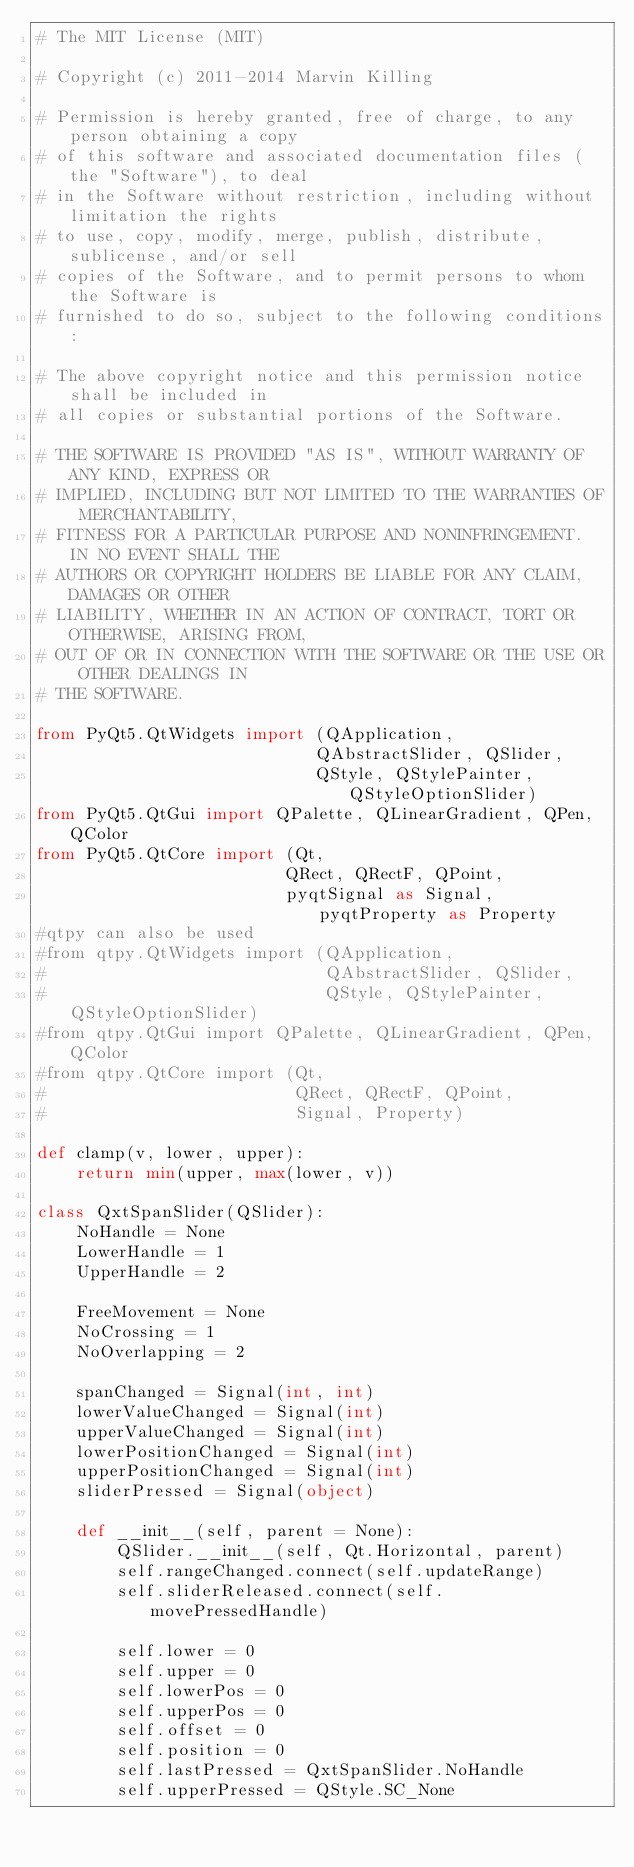<code> <loc_0><loc_0><loc_500><loc_500><_Python_># The MIT License (MIT)

# Copyright (c) 2011-2014 Marvin Killing

# Permission is hereby granted, free of charge, to any person obtaining a copy
# of this software and associated documentation files (the "Software"), to deal
# in the Software without restriction, including without limitation the rights
# to use, copy, modify, merge, publish, distribute, sublicense, and/or sell
# copies of the Software, and to permit persons to whom the Software is
# furnished to do so, subject to the following conditions:

# The above copyright notice and this permission notice shall be included in
# all copies or substantial portions of the Software.

# THE SOFTWARE IS PROVIDED "AS IS", WITHOUT WARRANTY OF ANY KIND, EXPRESS OR
# IMPLIED, INCLUDING BUT NOT LIMITED TO THE WARRANTIES OF MERCHANTABILITY,
# FITNESS FOR A PARTICULAR PURPOSE AND NONINFRINGEMENT. IN NO EVENT SHALL THE
# AUTHORS OR COPYRIGHT HOLDERS BE LIABLE FOR ANY CLAIM, DAMAGES OR OTHER
# LIABILITY, WHETHER IN AN ACTION OF CONTRACT, TORT OR OTHERWISE, ARISING FROM,
# OUT OF OR IN CONNECTION WITH THE SOFTWARE OR THE USE OR OTHER DEALINGS IN
# THE SOFTWARE.

from PyQt5.QtWidgets import (QApplication,
                            QAbstractSlider, QSlider,
                            QStyle, QStylePainter, QStyleOptionSlider)
from PyQt5.QtGui import QPalette, QLinearGradient, QPen, QColor
from PyQt5.QtCore import (Qt, 
                         QRect, QRectF, QPoint,
                         pyqtSignal as Signal, pyqtProperty as Property
#qtpy can also be used
#from qtpy.QtWidgets import (QApplication,
#                            QAbstractSlider, QSlider,
#                            QStyle, QStylePainter, QStyleOptionSlider)
#from qtpy.QtGui import QPalette, QLinearGradient, QPen, QColor
#from qtpy.QtCore import (Qt, 
#                         QRect, QRectF, QPoint,
#                         Signal, Property)

def clamp(v, lower, upper):
    return min(upper, max(lower, v))

class QxtSpanSlider(QSlider):
    NoHandle = None
    LowerHandle = 1
    UpperHandle = 2
    
    FreeMovement = None
    NoCrossing = 1
    NoOverlapping = 2
    
    spanChanged = Signal(int, int)
    lowerValueChanged = Signal(int)
    upperValueChanged = Signal(int)
    lowerPositionChanged = Signal(int)
    upperPositionChanged = Signal(int)
    sliderPressed = Signal(object)

    def __init__(self, parent = None):
        QSlider.__init__(self, Qt.Horizontal, parent)
        self.rangeChanged.connect(self.updateRange)
        self.sliderReleased.connect(self.movePressedHandle)

        self.lower = 0
        self.upper = 0
        self.lowerPos = 0
        self.upperPos = 0
        self.offset = 0
        self.position = 0
        self.lastPressed = QxtSpanSlider.NoHandle
        self.upperPressed = QStyle.SC_None</code> 